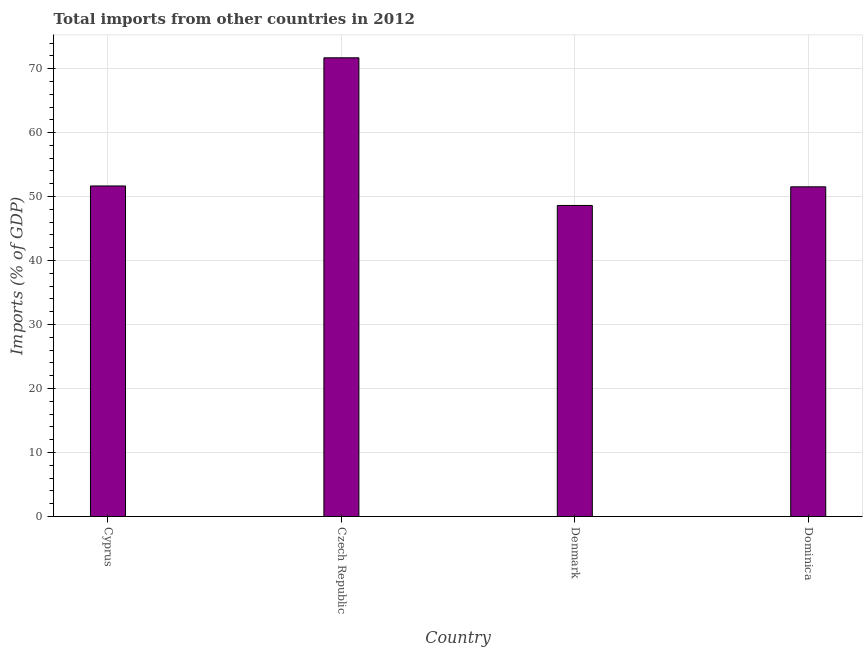Does the graph contain any zero values?
Ensure brevity in your answer.  No. Does the graph contain grids?
Provide a succinct answer. Yes. What is the title of the graph?
Your response must be concise. Total imports from other countries in 2012. What is the label or title of the X-axis?
Offer a very short reply. Country. What is the label or title of the Y-axis?
Provide a short and direct response. Imports (% of GDP). What is the total imports in Czech Republic?
Provide a succinct answer. 71.69. Across all countries, what is the maximum total imports?
Offer a terse response. 71.69. Across all countries, what is the minimum total imports?
Ensure brevity in your answer.  48.61. In which country was the total imports maximum?
Keep it short and to the point. Czech Republic. What is the sum of the total imports?
Your answer should be very brief. 223.49. What is the difference between the total imports in Cyprus and Czech Republic?
Your answer should be very brief. -20.03. What is the average total imports per country?
Make the answer very short. 55.87. What is the median total imports?
Keep it short and to the point. 51.59. In how many countries, is the total imports greater than 20 %?
Offer a terse response. 4. What is the difference between the highest and the second highest total imports?
Your answer should be compact. 20.03. What is the difference between the highest and the lowest total imports?
Ensure brevity in your answer.  23.08. In how many countries, is the total imports greater than the average total imports taken over all countries?
Make the answer very short. 1. Are all the bars in the graph horizontal?
Your answer should be very brief. No. What is the Imports (% of GDP) of Cyprus?
Provide a succinct answer. 51.66. What is the Imports (% of GDP) in Czech Republic?
Your response must be concise. 71.69. What is the Imports (% of GDP) in Denmark?
Ensure brevity in your answer.  48.61. What is the Imports (% of GDP) of Dominica?
Offer a very short reply. 51.53. What is the difference between the Imports (% of GDP) in Cyprus and Czech Republic?
Make the answer very short. -20.03. What is the difference between the Imports (% of GDP) in Cyprus and Denmark?
Give a very brief answer. 3.05. What is the difference between the Imports (% of GDP) in Cyprus and Dominica?
Offer a very short reply. 0.13. What is the difference between the Imports (% of GDP) in Czech Republic and Denmark?
Make the answer very short. 23.08. What is the difference between the Imports (% of GDP) in Czech Republic and Dominica?
Ensure brevity in your answer.  20.16. What is the difference between the Imports (% of GDP) in Denmark and Dominica?
Your response must be concise. -2.91. What is the ratio of the Imports (% of GDP) in Cyprus to that in Czech Republic?
Provide a succinct answer. 0.72. What is the ratio of the Imports (% of GDP) in Cyprus to that in Denmark?
Give a very brief answer. 1.06. What is the ratio of the Imports (% of GDP) in Czech Republic to that in Denmark?
Provide a succinct answer. 1.48. What is the ratio of the Imports (% of GDP) in Czech Republic to that in Dominica?
Keep it short and to the point. 1.39. What is the ratio of the Imports (% of GDP) in Denmark to that in Dominica?
Provide a succinct answer. 0.94. 